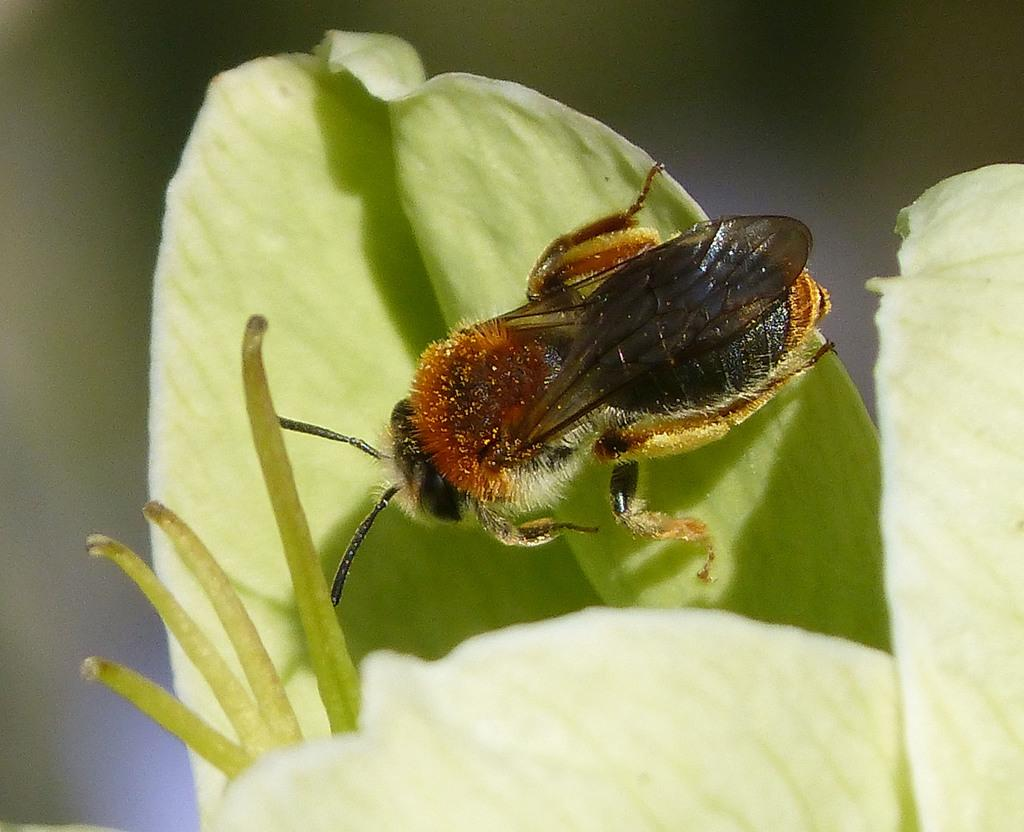What type of creature is present in the image? There is an insect in the image. What is the insect sitting on in the image? The insect is on a leaf. Where is the insect located in relation to the image? The insect is in the front of the image. What arithmetic problem is the insect trying to solve in the image? There is no indication in the image that the insect is trying to solve an arithmetic problem. What type of fruit is the insect eating in the image? There is no fruit, including cherry, present in the image. 